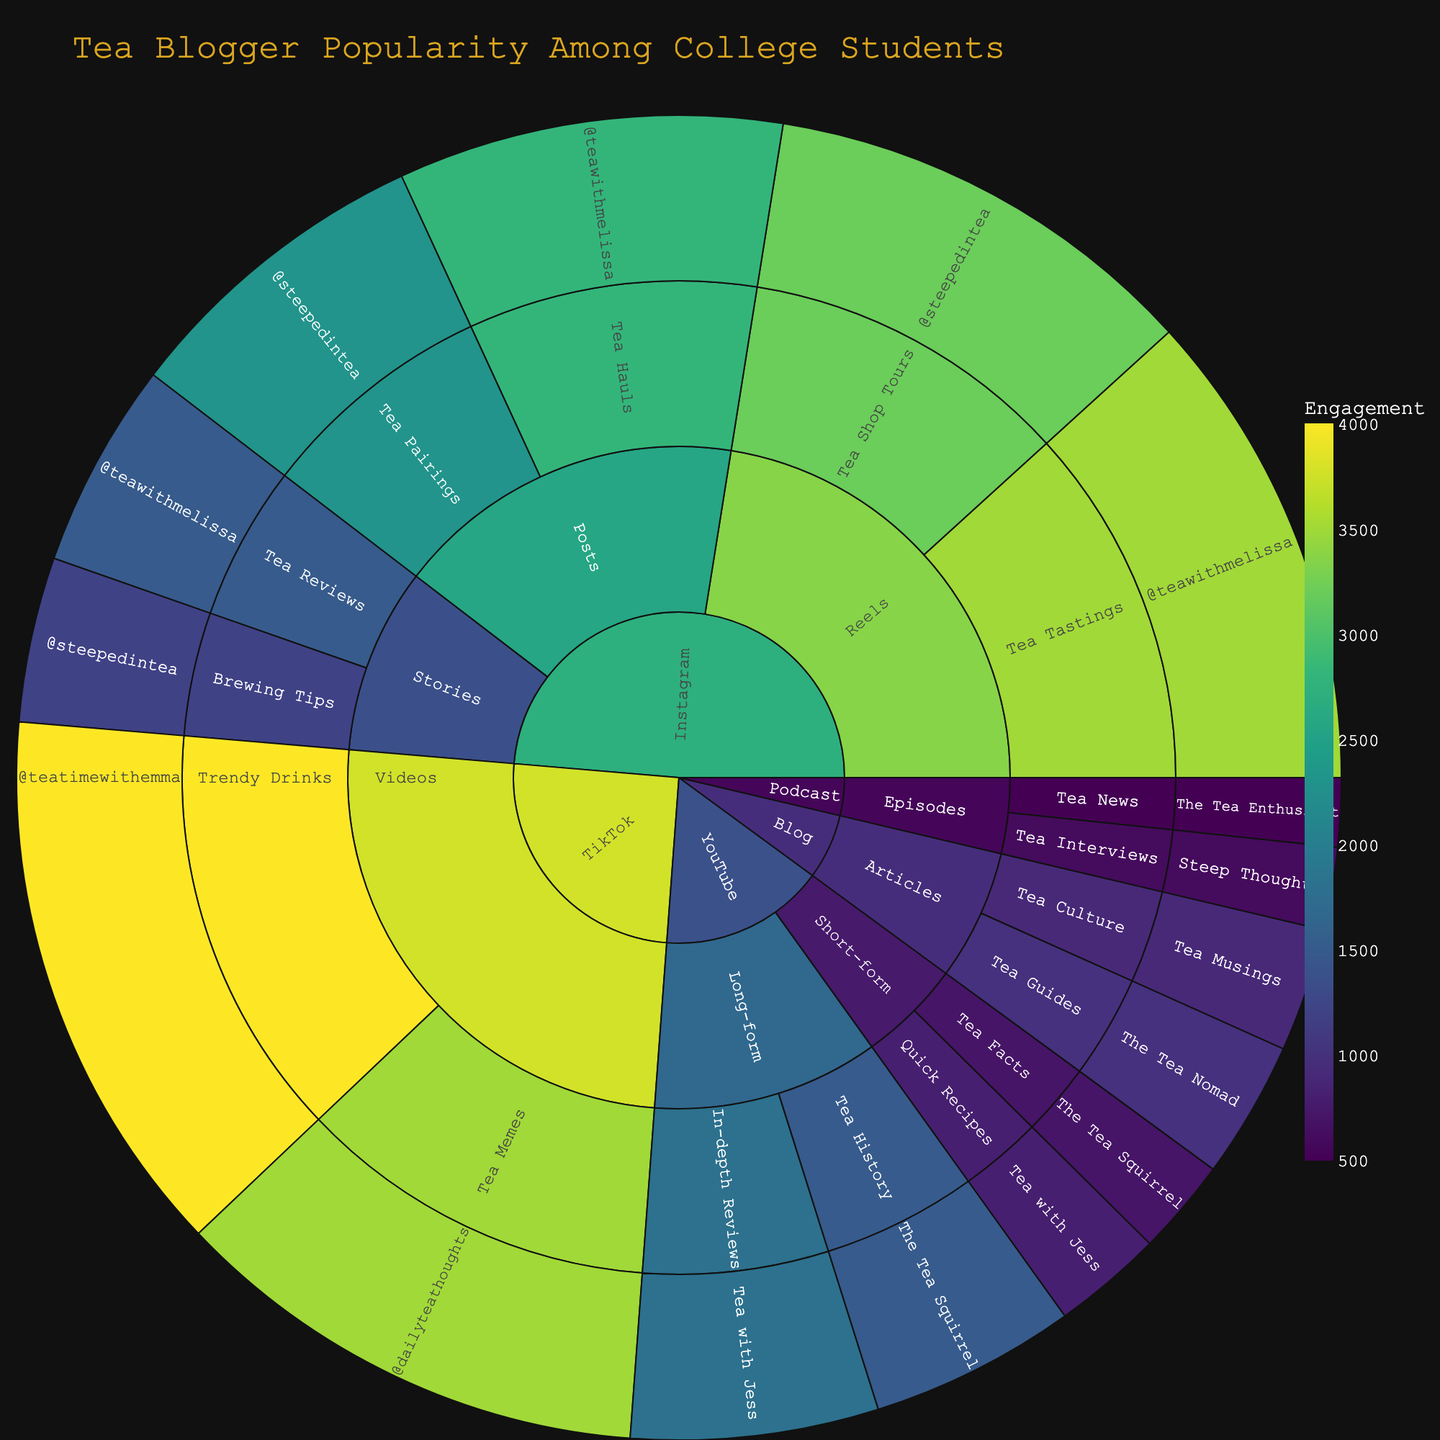What platform has the highest overall engagement with tea content? By examining the overall engagement for content categories under each platform, TikTok shows higher values for Videos.
Answer: TikTok How many engagements does @teawithmelissa have in total across all content types on Instagram? Sum the engagement for @teawithmelissa's content on Instagram (1500 for Stories, 2800 for Posts, 3500 for Reels) to get the total.
Answer: 7800 Compare the total engagement of the Tea Squirrel's content on YouTube to Tea with Jess's content on YouTube. Which has more engagement? Sum the engagements for The Tea Squirrel (700 + 1500) and for Tea with Jess (800 + 1800). The Tea Squirrel has 2200, while Tea with Jess has 2600.
Answer: Tea with Jess What's the average engagement for blog content? There are two blog content entries: 1000 (Tea Guides) and 900 (Tea Culture). The average is (1000 + 900) / 2.
Answer: 950 Which content type on Instagram receives higher engagement, Posts or Stories? Compare the combined engagement for Posts (2800 + 2300 = 5100) with that of Stories (1500 + 1200 = 2700).
Answer: Posts What content type does @dailyteathoughts create on TikTok, and how much engagement does it receive? By examining the TikTok section under Videos, @dailyteathoughts creates Tea Memes with 3500 engagements.
Answer: Tea Memes, 3500 Which blogger has the highest engagement for any single type of content, and what is the engagement value? Scan through all engagement values in the sunburst plot to identify that @teatimewithemma on TikTok has the highest single type engagement with 4000 engagements for Trendy Drinks.
Answer: @teatimewithemma, 4000 What is the total engagement across all Podcast content types? Sum the engagements for Tea Interviews (600) and Tea News (500).
Answer: 1100 Which YouTube content type has higher engagement, Short-form or Long-form, and by how much? The engagements for Short-form are 800 (Quick Recipes) + 700 (Tea Facts) = 1500, and for Long-form are 1800 (In-depth Reviews) + 1500 (Tea History) = 3300. The difference is 3300 - 1500.
Answer: Long-form, 1800 Which category has the widest variety of subcategories, and what are they? Instagram includes the most subcategories (Stories, Posts, Reels).
Answer: Instagram, Stories, Posts, Reels 